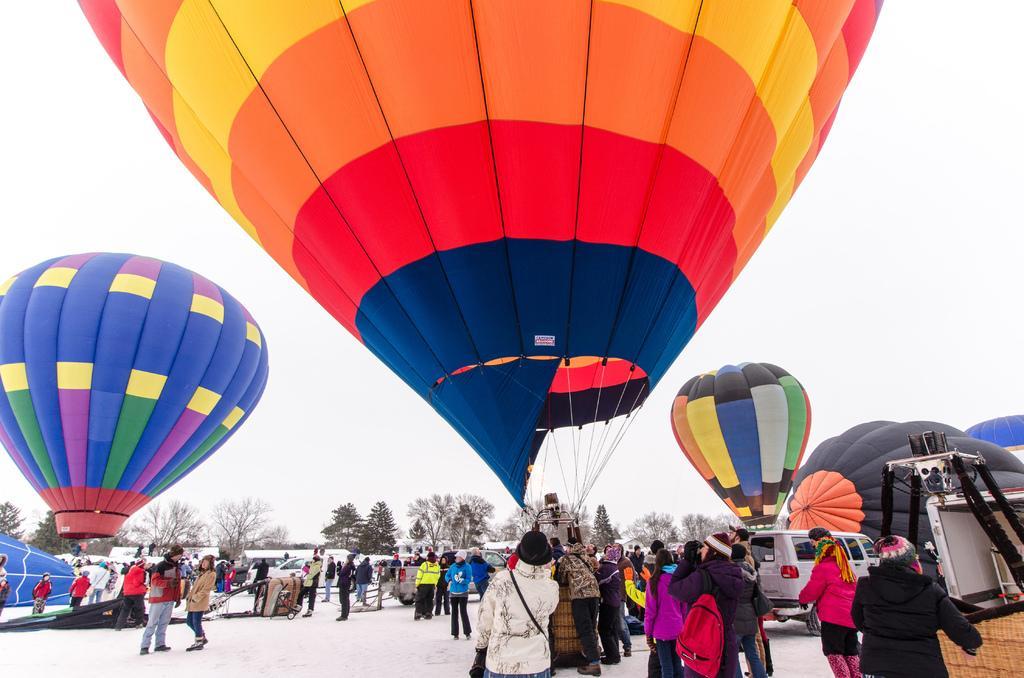How would you summarize this image in a sentence or two? In the picture I can see groups of people. In the middle of the picture I can see colorful parachutes. In the background of the picture I can see groups of trees. 